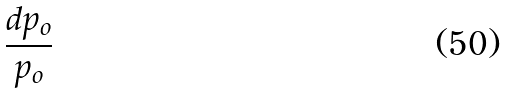<formula> <loc_0><loc_0><loc_500><loc_500>\frac { d p _ { o } } { p _ { o } }</formula> 